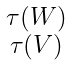Convert formula to latex. <formula><loc_0><loc_0><loc_500><loc_500>\begin{smallmatrix} \tau ( W ) \\ \tau ( V ) \end{smallmatrix}</formula> 